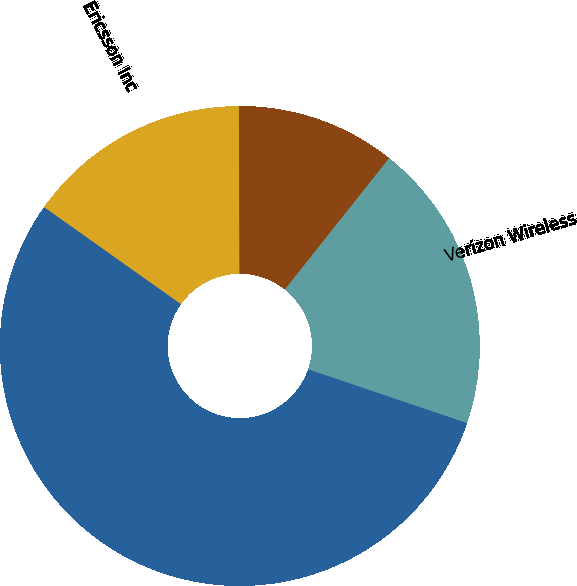Convert chart. <chart><loc_0><loc_0><loc_500><loc_500><pie_chart><fcel>Ericsson Inc<fcel>Nsoro Mastec LLC<fcel>Verizon Wireless<fcel>T-Mobile<nl><fcel>15.13%<fcel>54.62%<fcel>19.52%<fcel>10.74%<nl></chart> 